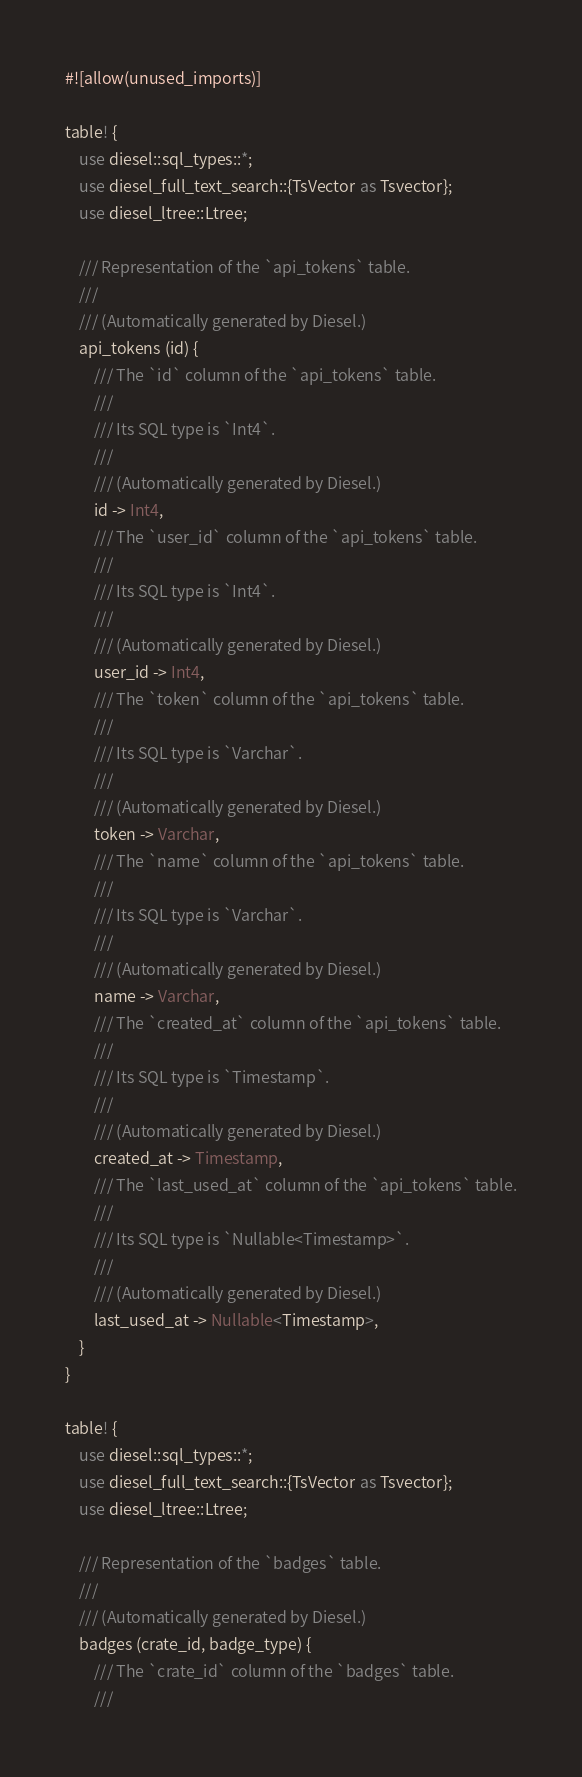Convert code to text. <code><loc_0><loc_0><loc_500><loc_500><_Rust_>#![allow(unused_imports)]

table! {
    use diesel::sql_types::*;
    use diesel_full_text_search::{TsVector as Tsvector};
    use diesel_ltree::Ltree;

    /// Representation of the `api_tokens` table.
    ///
    /// (Automatically generated by Diesel.)
    api_tokens (id) {
        /// The `id` column of the `api_tokens` table.
        ///
        /// Its SQL type is `Int4`.
        ///
        /// (Automatically generated by Diesel.)
        id -> Int4,
        /// The `user_id` column of the `api_tokens` table.
        ///
        /// Its SQL type is `Int4`.
        ///
        /// (Automatically generated by Diesel.)
        user_id -> Int4,
        /// The `token` column of the `api_tokens` table.
        ///
        /// Its SQL type is `Varchar`.
        ///
        /// (Automatically generated by Diesel.)
        token -> Varchar,
        /// The `name` column of the `api_tokens` table.
        ///
        /// Its SQL type is `Varchar`.
        ///
        /// (Automatically generated by Diesel.)
        name -> Varchar,
        /// The `created_at` column of the `api_tokens` table.
        ///
        /// Its SQL type is `Timestamp`.
        ///
        /// (Automatically generated by Diesel.)
        created_at -> Timestamp,
        /// The `last_used_at` column of the `api_tokens` table.
        ///
        /// Its SQL type is `Nullable<Timestamp>`.
        ///
        /// (Automatically generated by Diesel.)
        last_used_at -> Nullable<Timestamp>,
    }
}

table! {
    use diesel::sql_types::*;
    use diesel_full_text_search::{TsVector as Tsvector};
    use diesel_ltree::Ltree;

    /// Representation of the `badges` table.
    ///
    /// (Automatically generated by Diesel.)
    badges (crate_id, badge_type) {
        /// The `crate_id` column of the `badges` table.
        ///</code> 